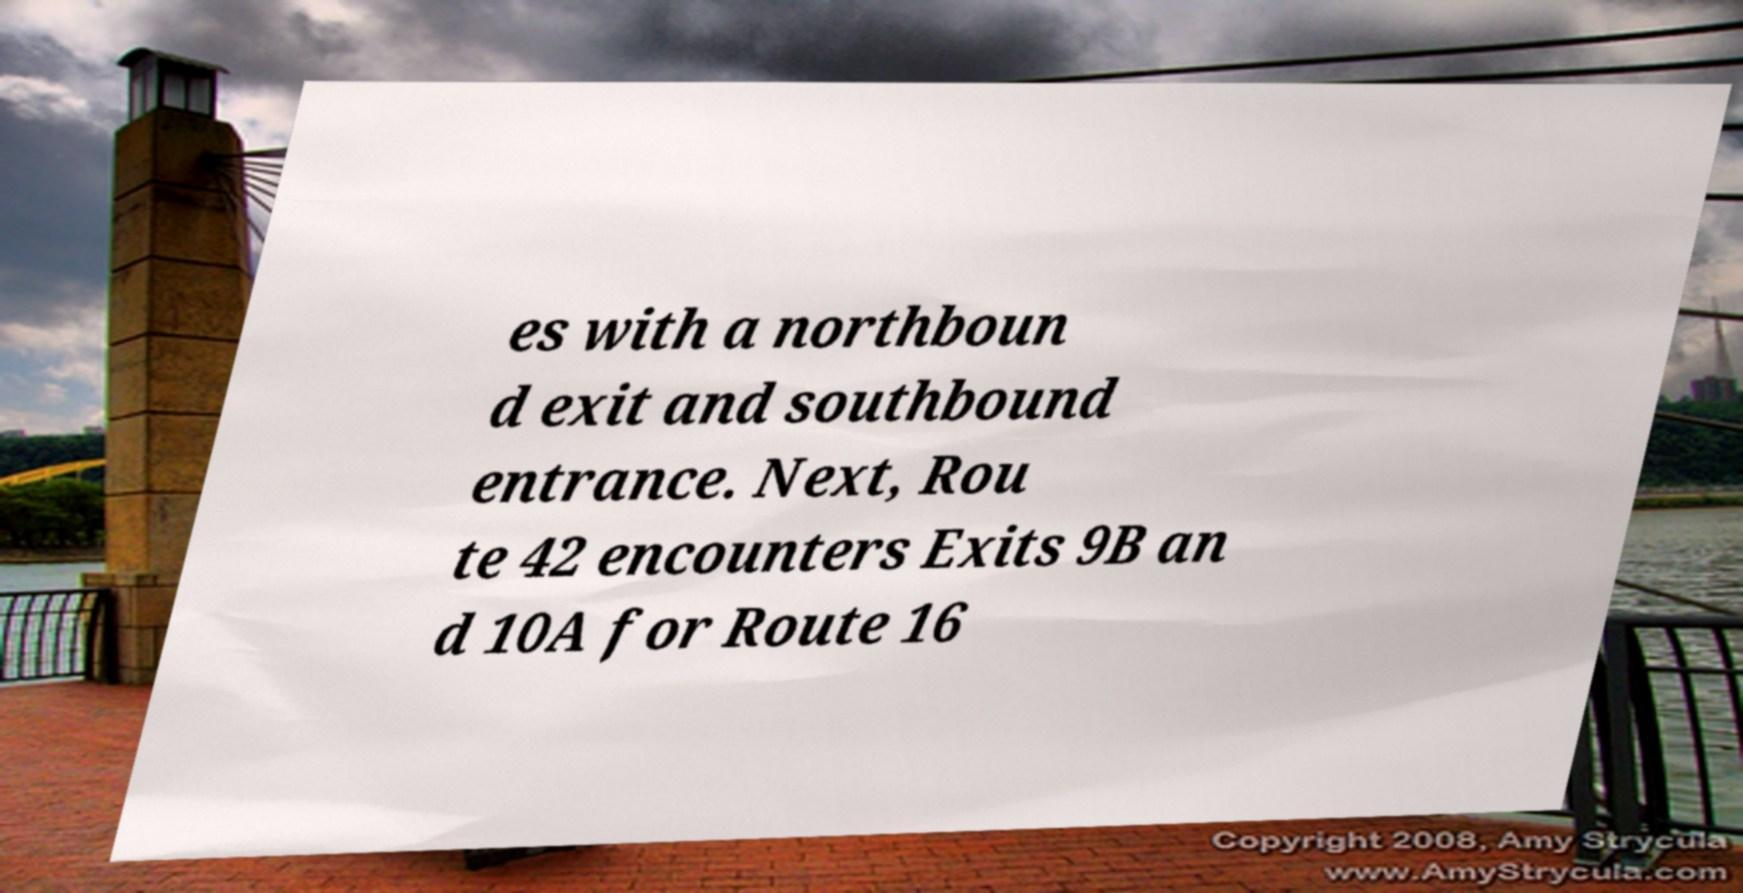Please read and relay the text visible in this image. What does it say? es with a northboun d exit and southbound entrance. Next, Rou te 42 encounters Exits 9B an d 10A for Route 16 